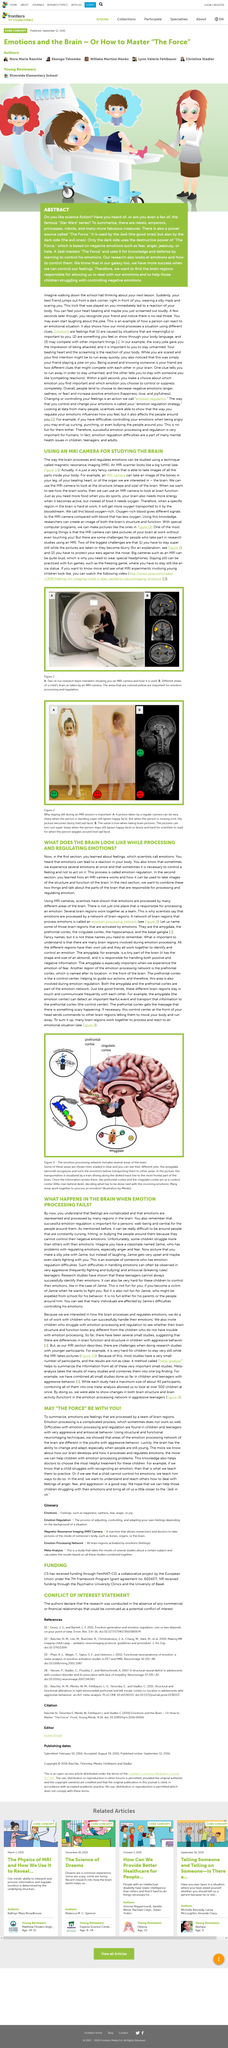Draw attention to some important aspects in this diagram. The machine they are using is an MRI. The paragraph discusses the Star Wars series. It is declared that the article will delve into the topic of which parts of the brain are responsible for processing and regulating emotions. Emotional regulation is the process of feeling an emotion but not acting on it, which allows an individual to manage their emotions and behavior appropriately in different situations. It is possible to use an MRI camera to image the brain. 